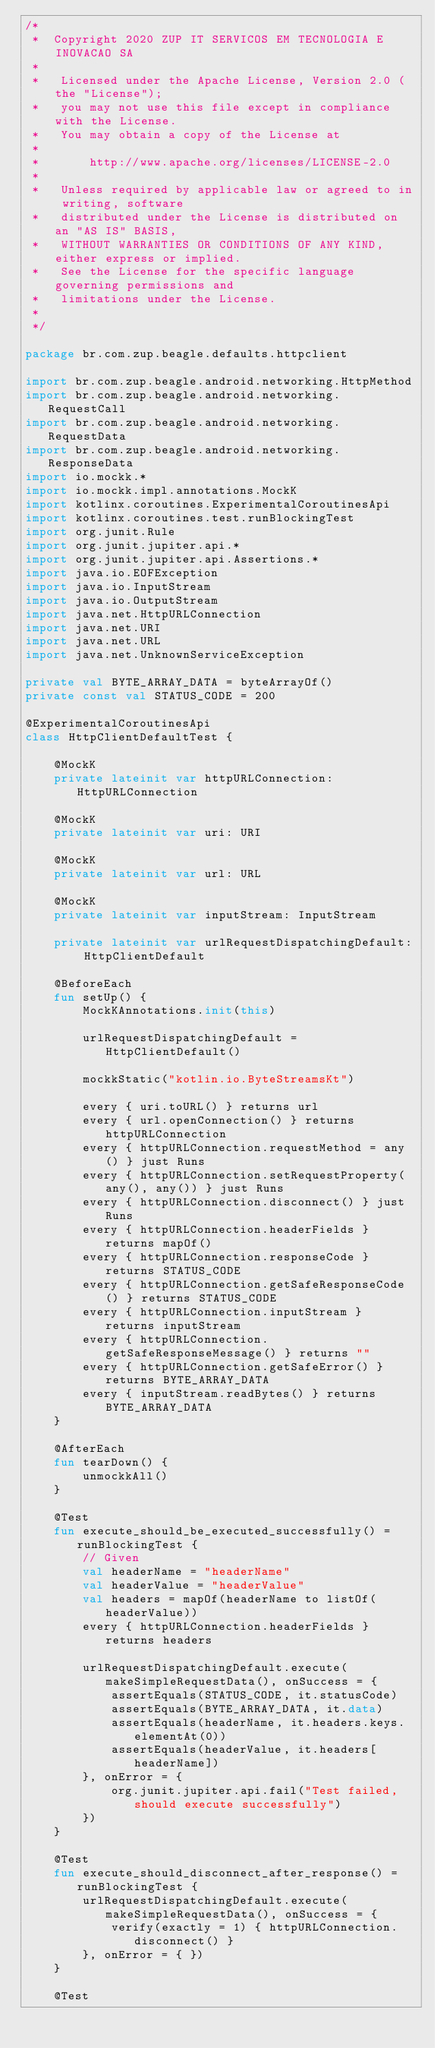Convert code to text. <code><loc_0><loc_0><loc_500><loc_500><_Kotlin_>/*
 *  Copyright 2020 ZUP IT SERVICOS EM TECNOLOGIA E INOVACAO SA
 *
 *   Licensed under the Apache License, Version 2.0 (the "License");
 *   you may not use this file except in compliance with the License.
 *   You may obtain a copy of the License at
 *
 *       http://www.apache.org/licenses/LICENSE-2.0
 *
 *   Unless required by applicable law or agreed to in writing, software
 *   distributed under the License is distributed on an "AS IS" BASIS,
 *   WITHOUT WARRANTIES OR CONDITIONS OF ANY KIND, either express or implied.
 *   See the License for the specific language governing permissions and
 *   limitations under the License.
 *
 */

package br.com.zup.beagle.defaults.httpclient

import br.com.zup.beagle.android.networking.HttpMethod
import br.com.zup.beagle.android.networking.RequestCall
import br.com.zup.beagle.android.networking.RequestData
import br.com.zup.beagle.android.networking.ResponseData
import io.mockk.*
import io.mockk.impl.annotations.MockK
import kotlinx.coroutines.ExperimentalCoroutinesApi
import kotlinx.coroutines.test.runBlockingTest
import org.junit.Rule
import org.junit.jupiter.api.*
import org.junit.jupiter.api.Assertions.*
import java.io.EOFException
import java.io.InputStream
import java.io.OutputStream
import java.net.HttpURLConnection
import java.net.URI
import java.net.URL
import java.net.UnknownServiceException

private val BYTE_ARRAY_DATA = byteArrayOf()
private const val STATUS_CODE = 200

@ExperimentalCoroutinesApi
class HttpClientDefaultTest {

    @MockK
    private lateinit var httpURLConnection: HttpURLConnection

    @MockK
    private lateinit var uri: URI

    @MockK
    private lateinit var url: URL

    @MockK
    private lateinit var inputStream: InputStream

    private lateinit var urlRequestDispatchingDefault: HttpClientDefault

    @BeforeEach
    fun setUp() {
        MockKAnnotations.init(this)

        urlRequestDispatchingDefault = HttpClientDefault()

        mockkStatic("kotlin.io.ByteStreamsKt")

        every { uri.toURL() } returns url
        every { url.openConnection() } returns httpURLConnection
        every { httpURLConnection.requestMethod = any() } just Runs
        every { httpURLConnection.setRequestProperty(any(), any()) } just Runs
        every { httpURLConnection.disconnect() } just Runs
        every { httpURLConnection.headerFields } returns mapOf()
        every { httpURLConnection.responseCode } returns STATUS_CODE
        every { httpURLConnection.getSafeResponseCode() } returns STATUS_CODE
        every { httpURLConnection.inputStream } returns inputStream
        every { httpURLConnection.getSafeResponseMessage() } returns ""
        every { httpURLConnection.getSafeError() } returns BYTE_ARRAY_DATA
        every { inputStream.readBytes() } returns BYTE_ARRAY_DATA
    }

    @AfterEach
    fun tearDown() {
        unmockkAll()
    }

    @Test
    fun execute_should_be_executed_successfully() = runBlockingTest {
        // Given
        val headerName = "headerName"
        val headerValue = "headerValue"
        val headers = mapOf(headerName to listOf(headerValue))
        every { httpURLConnection.headerFields } returns headers

        urlRequestDispatchingDefault.execute(makeSimpleRequestData(), onSuccess = {
            assertEquals(STATUS_CODE, it.statusCode)
            assertEquals(BYTE_ARRAY_DATA, it.data)
            assertEquals(headerName, it.headers.keys.elementAt(0))
            assertEquals(headerValue, it.headers[headerName])
        }, onError = {
            org.junit.jupiter.api.fail("Test failed, should execute successfully")
        })
    }

    @Test
    fun execute_should_disconnect_after_response() = runBlockingTest {
        urlRequestDispatchingDefault.execute(makeSimpleRequestData(), onSuccess = {
            verify(exactly = 1) { httpURLConnection.disconnect() }
        }, onError = { })
    }

    @Test</code> 